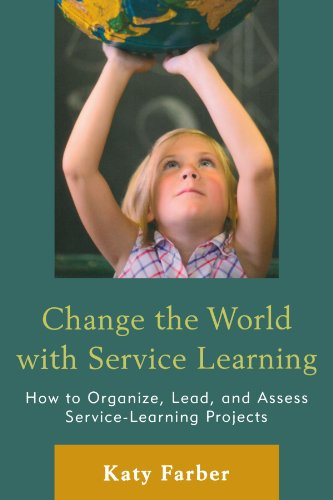How might this book be used in a school setting? In a school setting, this book can serve as a manual for teachers and administrators to create and assess effective service-learning projects that integrate educational goals with community service. It provides frameworks and examples that can be adapted for various educational programs and curricula. 